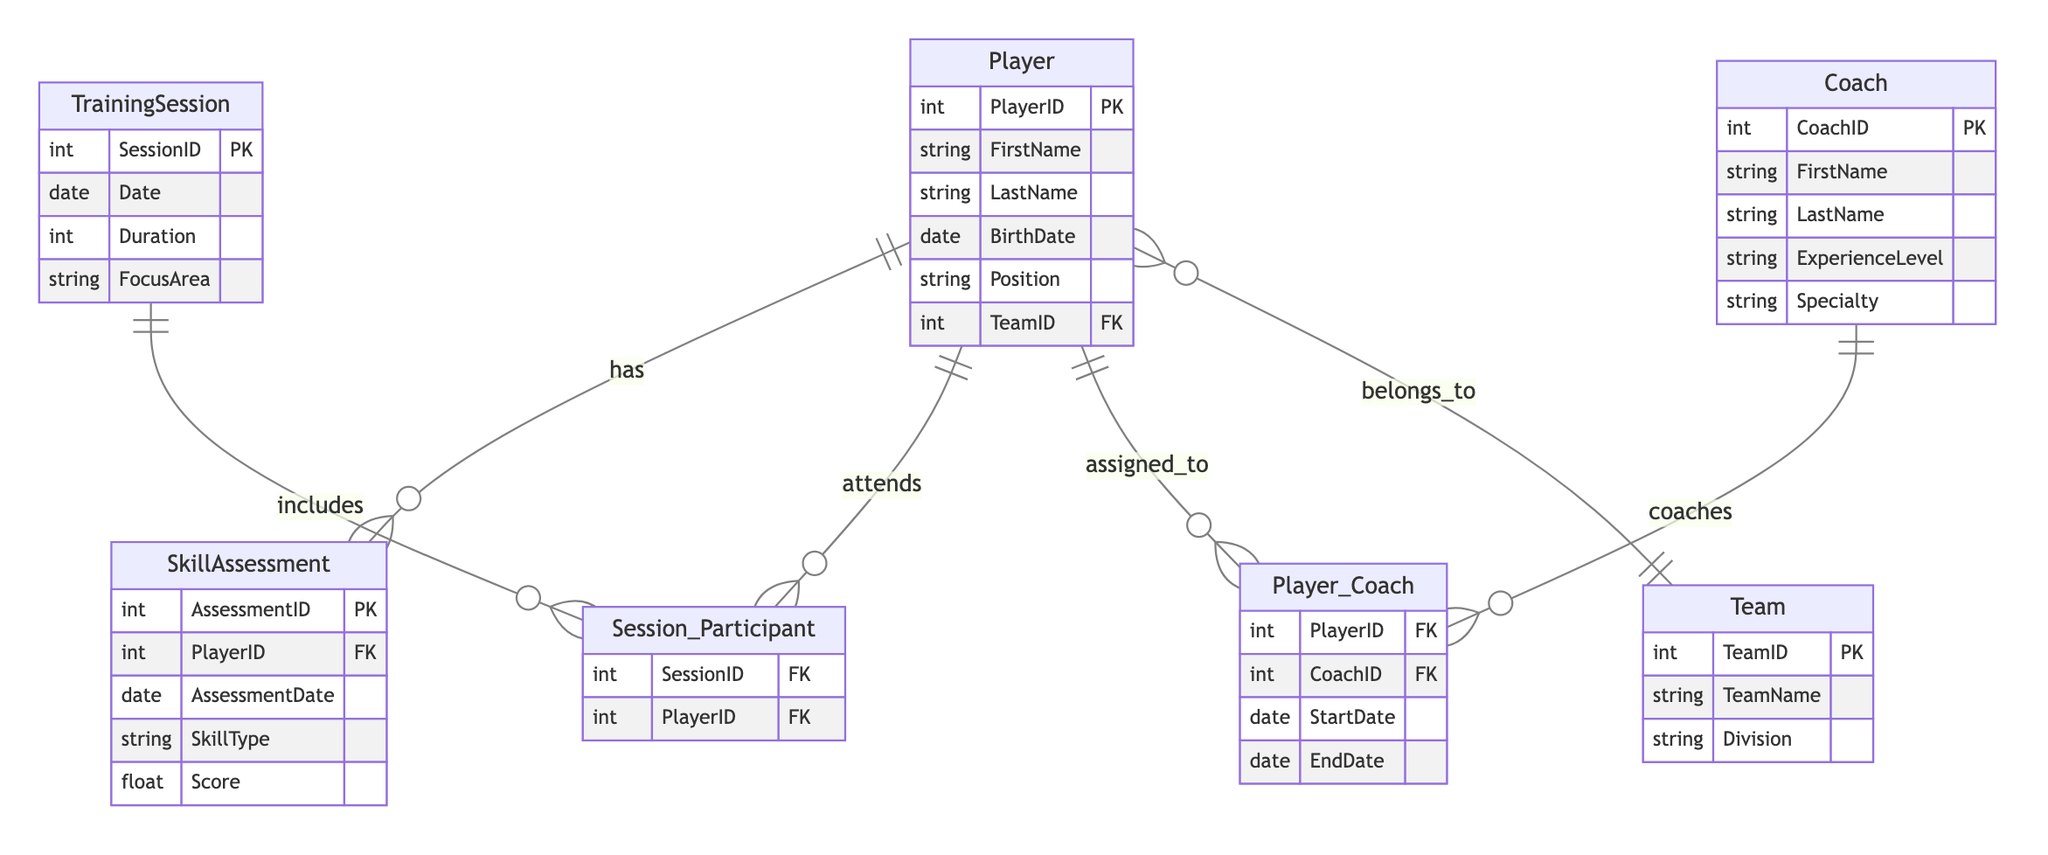What is the primary key of the Player entity? The primary key of the Player entity is specified in the diagram as PlayerID. It uniquely identifies each player in the system.
Answer: PlayerID How many attributes does the Coach entity have? The Coach entity has five attributes: CoachID, FirstName, LastName, ExperienceLevel, and Specialty. These represent the characteristics of a coach.
Answer: 5 What is the relationship between the Player and Coach entities? The relationship between Player and Coach entities is established through the Player_Coach entity, which connects them. This indicates players can be coached by one or more coaches.
Answer: Player_Coach Which entity includes a date attribute? The entities with a date attribute are TrainingSession, SkillAssessment, and Player_Coach. These indicate when training sessions occur, when skill assessments are conducted, and the duration for which a player is assigned to a coach, respectively.
Answer: TrainingSession, SkillAssessment, Player_Coach How many sessions can a player attend, based on the diagram? A player can attend multiple sessions, as indicated by the Session_Participant relationship connecting Player and TrainingSession entities. This means there are many-to-many relationships, allowing multiple participants per session.
Answer: Many What is the focus area of a TrainingSession? The focus area of a TrainingSession is an attribute within the TrainingSession entity. It specifies what the session is concentrated on, such as offense, defense, or conditioning.
Answer: FocusArea Which skill assessment type is related to a player? The SkillAssessment entity has a SkillType attribute that relates to the specific skills being assessed for each player. This indicates the skills are tracked and evaluated for development.
Answer: SkillType How is a player assigned to a coach? A player is assigned to a coach through the Player_Coach relationship that links the Player and Coach entities, indicating who coaches which player over a specific time period.
Answer: Player_Coach What are the primary keys of the Team entity? The primary key of the Team entity is TeamID, which uniquely identifies each team in the youth talent development program.
Answer: TeamID 